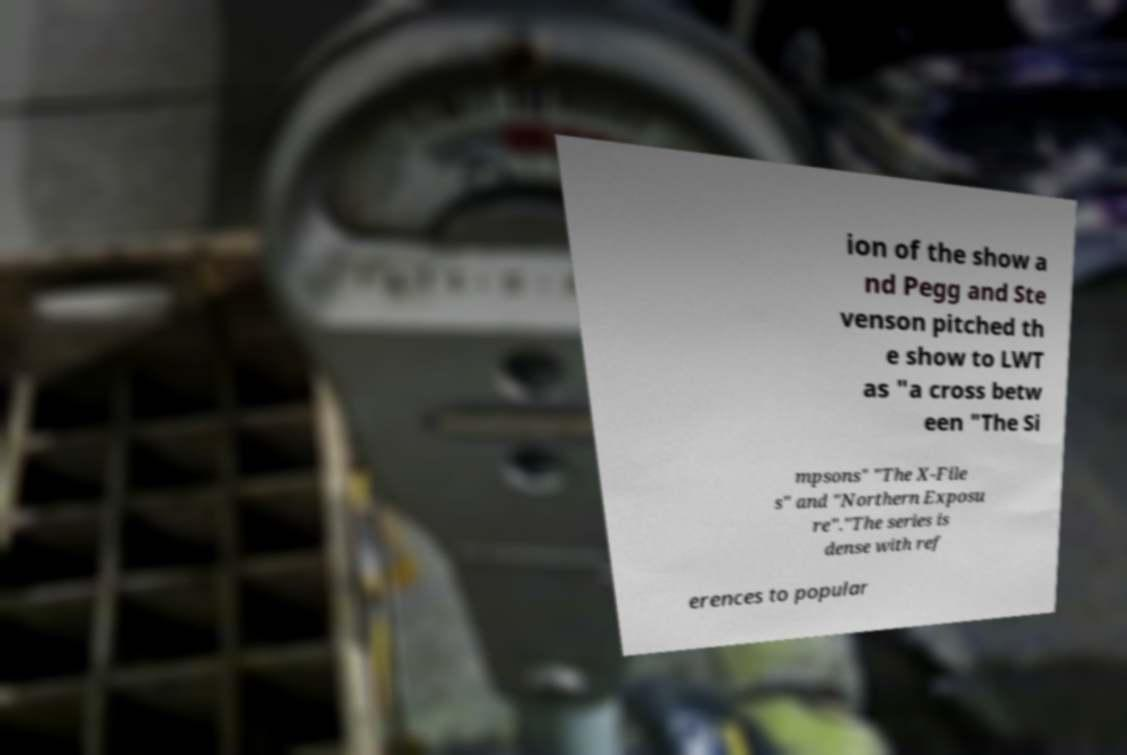Can you accurately transcribe the text from the provided image for me? ion of the show a nd Pegg and Ste venson pitched th e show to LWT as "a cross betw een "The Si mpsons" "The X-File s" and "Northern Exposu re"."The series is dense with ref erences to popular 